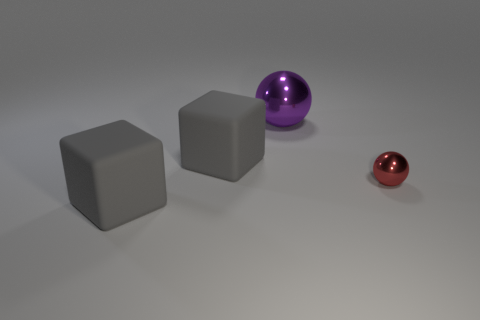There is another shiny thing that is the same shape as the tiny red shiny thing; what is its color?
Make the answer very short. Purple. Is the shape of the purple thing the same as the tiny red metallic object?
Make the answer very short. Yes. What size is the other red object that is the same shape as the large metallic thing?
Offer a terse response. Small. What number of big purple spheres have the same material as the red object?
Make the answer very short. 1. How many things are small cyan balls or red metal objects?
Make the answer very short. 1. Are there any small red shiny things that are left of the large gray block that is in front of the tiny red ball?
Ensure brevity in your answer.  No. Are there more purple metal objects to the right of the large purple shiny ball than small metallic objects in front of the red shiny thing?
Offer a very short reply. No. There is a ball that is to the right of the big metallic sphere; is its color the same as the big block that is in front of the small red metal object?
Offer a terse response. No. There is a big purple thing; are there any gray things left of it?
Keep it short and to the point. Yes. What material is the small thing?
Ensure brevity in your answer.  Metal. 